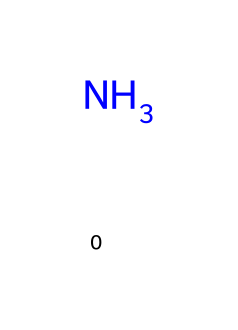What is the molecular formula of this chemical? The chemical structure depicted shows one nitrogen atom and three hydrogen atoms, which corresponds to the empirical formula NH3.
Answer: NH3 How many hydrogen atoms are present in this molecule? By analyzing the structure, we see that there are three hydrogen atoms bonded to the nitrogen atom.
Answer: 3 What type of bonding is present in ammonia? Ammonia has covalent bonds between the nitrogen and hydrogen atoms, as they share electrons to achieve stability.
Answer: covalent Is ammonia a greenhouse gas? Ammonia itself is not classified as a greenhouse gas, although it is involved in atmospheric reactions that can contribute to greenhouse gases.
Answer: no What property allows ammonia to be used as a refrigerant? Ammonia has a high latent heat of vaporization, which means it can effectively absorb heat when it evaporates, making it suitable for cooling applications.
Answer: high latent heat Why is ammonia considered a natural refrigerant? Ammonia is classified as a natural refrigerant because it occurs naturally in the environment and has low environmental impact compared to synthetic refrigerants.
Answer: low environmental impact 